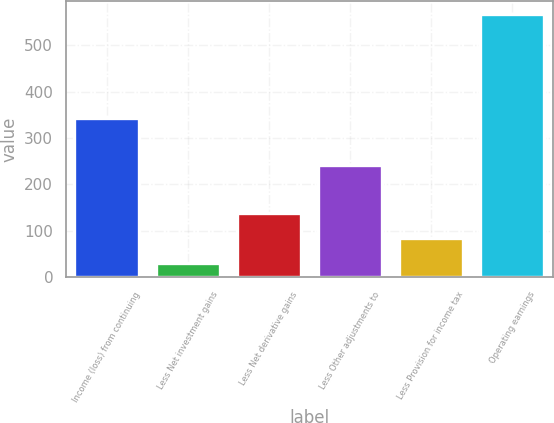Convert chart. <chart><loc_0><loc_0><loc_500><loc_500><bar_chart><fcel>Income (loss) from continuing<fcel>Less Net investment gains<fcel>Less Net derivative gains<fcel>Less Other adjustments to<fcel>Less Provision for income tax<fcel>Operating earnings<nl><fcel>344<fcel>30<fcel>137.6<fcel>242<fcel>83.8<fcel>568<nl></chart> 